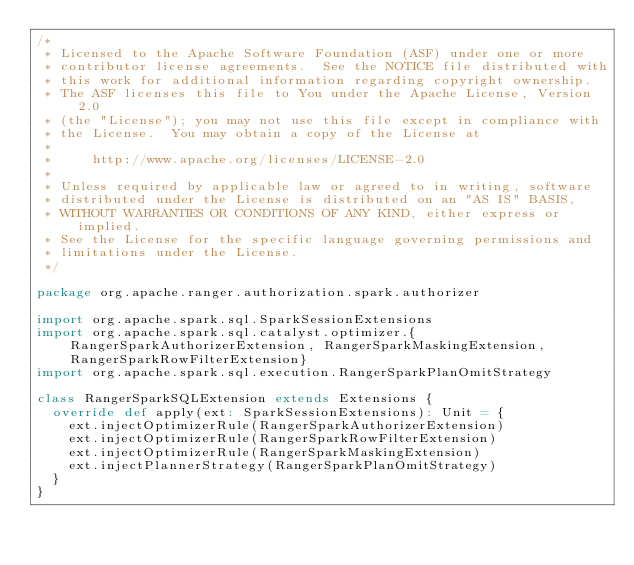<code> <loc_0><loc_0><loc_500><loc_500><_Scala_>/*
 * Licensed to the Apache Software Foundation (ASF) under one or more
 * contributor license agreements.  See the NOTICE file distributed with
 * this work for additional information regarding copyright ownership.
 * The ASF licenses this file to You under the Apache License, Version 2.0
 * (the "License"); you may not use this file except in compliance with
 * the License.  You may obtain a copy of the License at
 *
 *     http://www.apache.org/licenses/LICENSE-2.0
 *
 * Unless required by applicable law or agreed to in writing, software
 * distributed under the License is distributed on an "AS IS" BASIS,
 * WITHOUT WARRANTIES OR CONDITIONS OF ANY KIND, either express or implied.
 * See the License for the specific language governing permissions and
 * limitations under the License.
 */

package org.apache.ranger.authorization.spark.authorizer

import org.apache.spark.sql.SparkSessionExtensions
import org.apache.spark.sql.catalyst.optimizer.{RangerSparkAuthorizerExtension, RangerSparkMaskingExtension, RangerSparkRowFilterExtension}
import org.apache.spark.sql.execution.RangerSparkPlanOmitStrategy

class RangerSparkSQLExtension extends Extensions {
  override def apply(ext: SparkSessionExtensions): Unit = {
    ext.injectOptimizerRule(RangerSparkAuthorizerExtension)
    ext.injectOptimizerRule(RangerSparkRowFilterExtension)
    ext.injectOptimizerRule(RangerSparkMaskingExtension)
    ext.injectPlannerStrategy(RangerSparkPlanOmitStrategy)
  }
}
</code> 